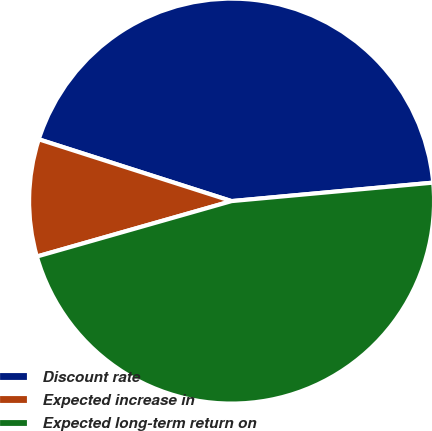Convert chart to OTSL. <chart><loc_0><loc_0><loc_500><loc_500><pie_chart><fcel>Discount rate<fcel>Expected increase in<fcel>Expected long-term return on<nl><fcel>43.61%<fcel>9.35%<fcel>47.04%<nl></chart> 